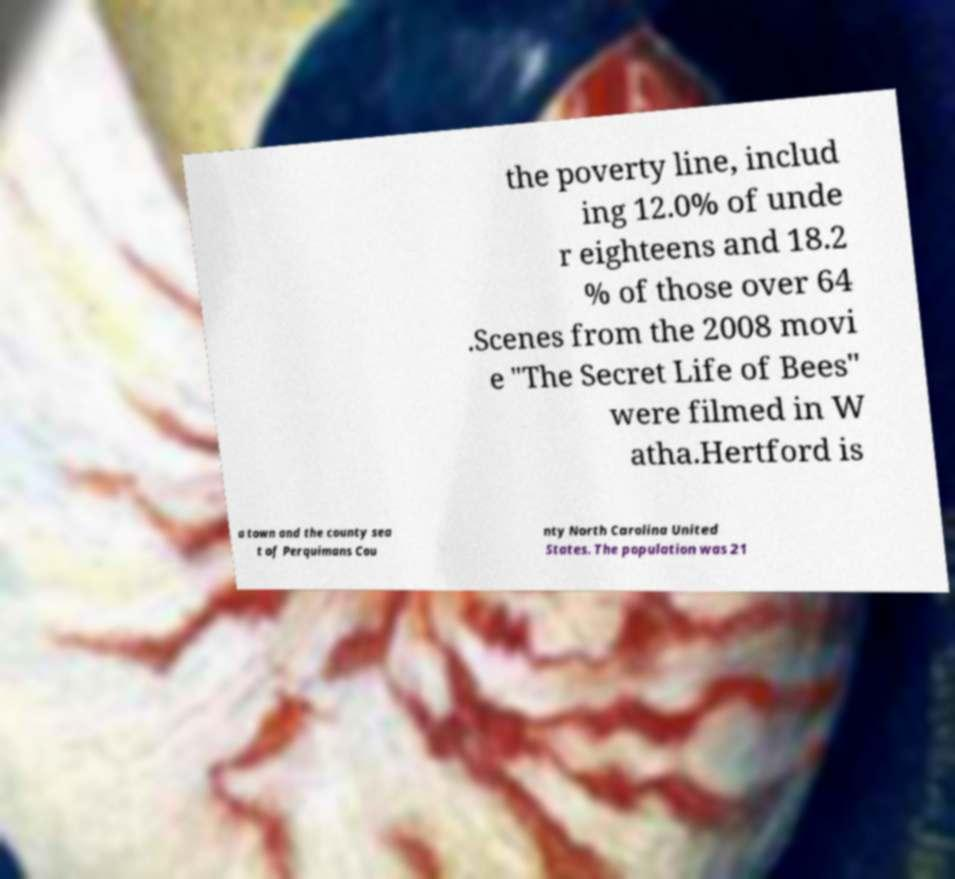For documentation purposes, I need the text within this image transcribed. Could you provide that? the poverty line, includ ing 12.0% of unde r eighteens and 18.2 % of those over 64 .Scenes from the 2008 movi e "The Secret Life of Bees" were filmed in W atha.Hertford is a town and the county sea t of Perquimans Cou nty North Carolina United States. The population was 21 